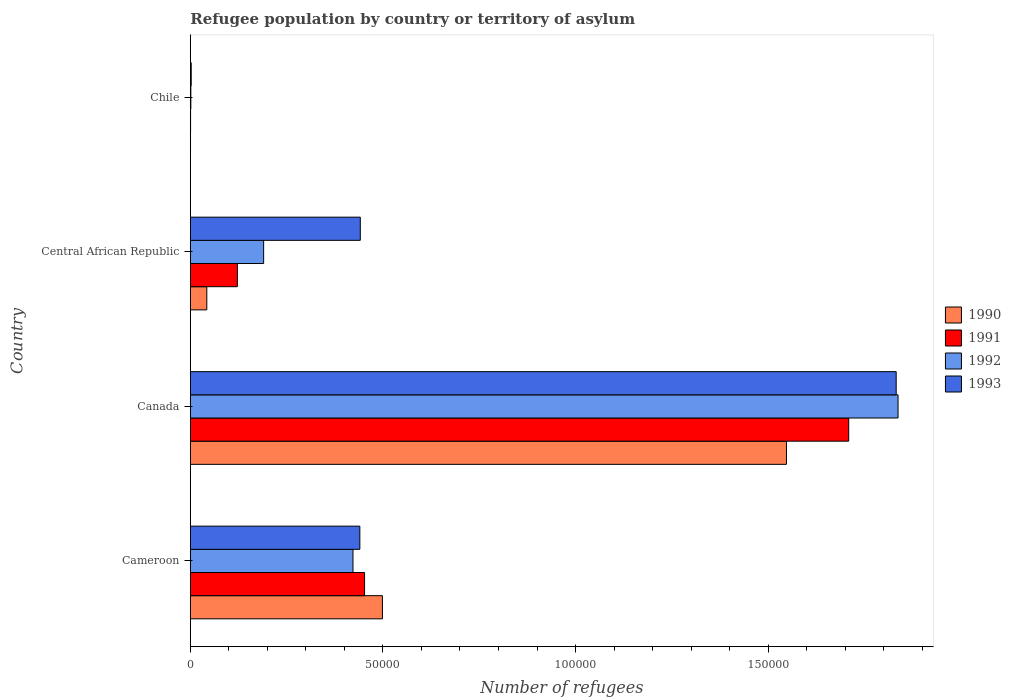How many different coloured bars are there?
Make the answer very short. 4. How many groups of bars are there?
Ensure brevity in your answer.  4. Are the number of bars on each tick of the Y-axis equal?
Your response must be concise. Yes. How many bars are there on the 2nd tick from the top?
Provide a short and direct response. 4. How many bars are there on the 1st tick from the bottom?
Your response must be concise. 4. What is the label of the 4th group of bars from the top?
Offer a terse response. Cameroon. In how many cases, is the number of bars for a given country not equal to the number of legend labels?
Keep it short and to the point. 0. What is the number of refugees in 1992 in Chile?
Ensure brevity in your answer.  142. Across all countries, what is the maximum number of refugees in 1993?
Offer a terse response. 1.83e+05. In which country was the number of refugees in 1991 maximum?
Ensure brevity in your answer.  Canada. What is the total number of refugees in 1990 in the graph?
Your response must be concise. 2.09e+05. What is the difference between the number of refugees in 1991 in Central African Republic and that in Chile?
Provide a succinct answer. 1.22e+04. What is the difference between the number of refugees in 1993 in Chile and the number of refugees in 1990 in Canada?
Make the answer very short. -1.55e+05. What is the average number of refugees in 1990 per country?
Make the answer very short. 5.22e+04. What is the difference between the number of refugees in 1990 and number of refugees in 1992 in Canada?
Make the answer very short. -2.90e+04. What is the ratio of the number of refugees in 1990 in Central African Republic to that in Chile?
Provide a short and direct response. 73.86. Is the number of refugees in 1993 in Cameroon less than that in Chile?
Keep it short and to the point. No. Is the difference between the number of refugees in 1990 in Cameroon and Chile greater than the difference between the number of refugees in 1992 in Cameroon and Chile?
Provide a short and direct response. Yes. What is the difference between the highest and the second highest number of refugees in 1992?
Make the answer very short. 1.41e+05. What is the difference between the highest and the lowest number of refugees in 1990?
Offer a terse response. 1.55e+05. In how many countries, is the number of refugees in 1991 greater than the average number of refugees in 1991 taken over all countries?
Keep it short and to the point. 1. Is the sum of the number of refugees in 1990 in Cameroon and Central African Republic greater than the maximum number of refugees in 1993 across all countries?
Offer a very short reply. No. Is it the case that in every country, the sum of the number of refugees in 1990 and number of refugees in 1993 is greater than the number of refugees in 1992?
Give a very brief answer. Yes. How many bars are there?
Give a very brief answer. 16. Are all the bars in the graph horizontal?
Keep it short and to the point. Yes. What is the difference between two consecutive major ticks on the X-axis?
Provide a short and direct response. 5.00e+04. Does the graph contain grids?
Offer a terse response. No. What is the title of the graph?
Ensure brevity in your answer.  Refugee population by country or territory of asylum. What is the label or title of the X-axis?
Provide a short and direct response. Number of refugees. What is the Number of refugees of 1990 in Cameroon?
Offer a very short reply. 4.99e+04. What is the Number of refugees in 1991 in Cameroon?
Your answer should be compact. 4.52e+04. What is the Number of refugees in 1992 in Cameroon?
Offer a terse response. 4.22e+04. What is the Number of refugees of 1993 in Cameroon?
Make the answer very short. 4.40e+04. What is the Number of refugees in 1990 in Canada?
Your answer should be very brief. 1.55e+05. What is the Number of refugees of 1991 in Canada?
Offer a terse response. 1.71e+05. What is the Number of refugees in 1992 in Canada?
Offer a very short reply. 1.84e+05. What is the Number of refugees in 1993 in Canada?
Ensure brevity in your answer.  1.83e+05. What is the Number of refugees in 1990 in Central African Republic?
Give a very brief answer. 4284. What is the Number of refugees in 1991 in Central African Republic?
Provide a succinct answer. 1.22e+04. What is the Number of refugees of 1992 in Central African Republic?
Ensure brevity in your answer.  1.90e+04. What is the Number of refugees of 1993 in Central African Republic?
Your answer should be compact. 4.41e+04. What is the Number of refugees of 1992 in Chile?
Offer a terse response. 142. What is the Number of refugees in 1993 in Chile?
Offer a terse response. 239. Across all countries, what is the maximum Number of refugees in 1990?
Offer a very short reply. 1.55e+05. Across all countries, what is the maximum Number of refugees in 1991?
Provide a short and direct response. 1.71e+05. Across all countries, what is the maximum Number of refugees of 1992?
Keep it short and to the point. 1.84e+05. Across all countries, what is the maximum Number of refugees in 1993?
Your response must be concise. 1.83e+05. Across all countries, what is the minimum Number of refugees in 1990?
Ensure brevity in your answer.  58. Across all countries, what is the minimum Number of refugees of 1991?
Your response must be concise. 72. Across all countries, what is the minimum Number of refugees in 1992?
Provide a short and direct response. 142. Across all countries, what is the minimum Number of refugees in 1993?
Give a very brief answer. 239. What is the total Number of refugees in 1990 in the graph?
Keep it short and to the point. 2.09e+05. What is the total Number of refugees of 1991 in the graph?
Give a very brief answer. 2.28e+05. What is the total Number of refugees in 1992 in the graph?
Ensure brevity in your answer.  2.45e+05. What is the total Number of refugees in 1993 in the graph?
Your response must be concise. 2.72e+05. What is the difference between the Number of refugees in 1990 in Cameroon and that in Canada?
Give a very brief answer. -1.05e+05. What is the difference between the Number of refugees in 1991 in Cameroon and that in Canada?
Keep it short and to the point. -1.26e+05. What is the difference between the Number of refugees in 1992 in Cameroon and that in Canada?
Your response must be concise. -1.41e+05. What is the difference between the Number of refugees in 1993 in Cameroon and that in Canada?
Provide a short and direct response. -1.39e+05. What is the difference between the Number of refugees of 1990 in Cameroon and that in Central African Republic?
Give a very brief answer. 4.56e+04. What is the difference between the Number of refugees of 1991 in Cameroon and that in Central African Republic?
Your answer should be very brief. 3.30e+04. What is the difference between the Number of refugees in 1992 in Cameroon and that in Central African Republic?
Offer a very short reply. 2.32e+04. What is the difference between the Number of refugees in 1993 in Cameroon and that in Central African Republic?
Your answer should be compact. -116. What is the difference between the Number of refugees of 1990 in Cameroon and that in Chile?
Your answer should be compact. 4.98e+04. What is the difference between the Number of refugees of 1991 in Cameroon and that in Chile?
Offer a very short reply. 4.52e+04. What is the difference between the Number of refugees in 1992 in Cameroon and that in Chile?
Ensure brevity in your answer.  4.21e+04. What is the difference between the Number of refugees of 1993 in Cameroon and that in Chile?
Offer a very short reply. 4.38e+04. What is the difference between the Number of refugees in 1990 in Canada and that in Central African Republic?
Give a very brief answer. 1.50e+05. What is the difference between the Number of refugees in 1991 in Canada and that in Central African Republic?
Your response must be concise. 1.59e+05. What is the difference between the Number of refugees in 1992 in Canada and that in Central African Republic?
Offer a terse response. 1.65e+05. What is the difference between the Number of refugees of 1993 in Canada and that in Central African Republic?
Provide a succinct answer. 1.39e+05. What is the difference between the Number of refugees in 1990 in Canada and that in Chile?
Offer a terse response. 1.55e+05. What is the difference between the Number of refugees in 1991 in Canada and that in Chile?
Make the answer very short. 1.71e+05. What is the difference between the Number of refugees of 1992 in Canada and that in Chile?
Your answer should be very brief. 1.84e+05. What is the difference between the Number of refugees of 1993 in Canada and that in Chile?
Make the answer very short. 1.83e+05. What is the difference between the Number of refugees in 1990 in Central African Republic and that in Chile?
Offer a terse response. 4226. What is the difference between the Number of refugees of 1991 in Central African Republic and that in Chile?
Provide a short and direct response. 1.22e+04. What is the difference between the Number of refugees of 1992 in Central African Republic and that in Chile?
Give a very brief answer. 1.89e+04. What is the difference between the Number of refugees in 1993 in Central African Republic and that in Chile?
Offer a terse response. 4.39e+04. What is the difference between the Number of refugees in 1990 in Cameroon and the Number of refugees in 1991 in Canada?
Your answer should be very brief. -1.21e+05. What is the difference between the Number of refugees in 1990 in Cameroon and the Number of refugees in 1992 in Canada?
Offer a terse response. -1.34e+05. What is the difference between the Number of refugees of 1990 in Cameroon and the Number of refugees of 1993 in Canada?
Give a very brief answer. -1.33e+05. What is the difference between the Number of refugees in 1991 in Cameroon and the Number of refugees in 1992 in Canada?
Offer a terse response. -1.38e+05. What is the difference between the Number of refugees of 1991 in Cameroon and the Number of refugees of 1993 in Canada?
Offer a terse response. -1.38e+05. What is the difference between the Number of refugees of 1992 in Cameroon and the Number of refugees of 1993 in Canada?
Your answer should be compact. -1.41e+05. What is the difference between the Number of refugees of 1990 in Cameroon and the Number of refugees of 1991 in Central African Republic?
Your response must be concise. 3.77e+04. What is the difference between the Number of refugees in 1990 in Cameroon and the Number of refugees in 1992 in Central African Republic?
Keep it short and to the point. 3.08e+04. What is the difference between the Number of refugees in 1990 in Cameroon and the Number of refugees in 1993 in Central African Republic?
Provide a short and direct response. 5747. What is the difference between the Number of refugees of 1991 in Cameroon and the Number of refugees of 1992 in Central African Republic?
Your answer should be compact. 2.62e+04. What is the difference between the Number of refugees of 1991 in Cameroon and the Number of refugees of 1993 in Central African Republic?
Ensure brevity in your answer.  1108. What is the difference between the Number of refugees of 1992 in Cameroon and the Number of refugees of 1993 in Central African Republic?
Make the answer very short. -1896. What is the difference between the Number of refugees of 1990 in Cameroon and the Number of refugees of 1991 in Chile?
Provide a short and direct response. 4.98e+04. What is the difference between the Number of refugees of 1990 in Cameroon and the Number of refugees of 1992 in Chile?
Provide a short and direct response. 4.97e+04. What is the difference between the Number of refugees in 1990 in Cameroon and the Number of refugees in 1993 in Chile?
Offer a very short reply. 4.96e+04. What is the difference between the Number of refugees in 1991 in Cameroon and the Number of refugees in 1992 in Chile?
Give a very brief answer. 4.51e+04. What is the difference between the Number of refugees in 1991 in Cameroon and the Number of refugees in 1993 in Chile?
Keep it short and to the point. 4.50e+04. What is the difference between the Number of refugees of 1992 in Cameroon and the Number of refugees of 1993 in Chile?
Make the answer very short. 4.20e+04. What is the difference between the Number of refugees in 1990 in Canada and the Number of refugees in 1991 in Central African Republic?
Ensure brevity in your answer.  1.43e+05. What is the difference between the Number of refugees of 1990 in Canada and the Number of refugees of 1992 in Central African Republic?
Offer a terse response. 1.36e+05. What is the difference between the Number of refugees in 1990 in Canada and the Number of refugees in 1993 in Central African Republic?
Your answer should be compact. 1.11e+05. What is the difference between the Number of refugees in 1991 in Canada and the Number of refugees in 1992 in Central African Republic?
Keep it short and to the point. 1.52e+05. What is the difference between the Number of refugees of 1991 in Canada and the Number of refugees of 1993 in Central African Republic?
Offer a terse response. 1.27e+05. What is the difference between the Number of refugees of 1992 in Canada and the Number of refugees of 1993 in Central African Republic?
Your answer should be compact. 1.40e+05. What is the difference between the Number of refugees of 1990 in Canada and the Number of refugees of 1991 in Chile?
Offer a very short reply. 1.55e+05. What is the difference between the Number of refugees of 1990 in Canada and the Number of refugees of 1992 in Chile?
Provide a succinct answer. 1.55e+05. What is the difference between the Number of refugees of 1990 in Canada and the Number of refugees of 1993 in Chile?
Ensure brevity in your answer.  1.55e+05. What is the difference between the Number of refugees of 1991 in Canada and the Number of refugees of 1992 in Chile?
Your answer should be very brief. 1.71e+05. What is the difference between the Number of refugees in 1991 in Canada and the Number of refugees in 1993 in Chile?
Keep it short and to the point. 1.71e+05. What is the difference between the Number of refugees in 1992 in Canada and the Number of refugees in 1993 in Chile?
Your answer should be compact. 1.83e+05. What is the difference between the Number of refugees in 1990 in Central African Republic and the Number of refugees in 1991 in Chile?
Provide a succinct answer. 4212. What is the difference between the Number of refugees of 1990 in Central African Republic and the Number of refugees of 1992 in Chile?
Provide a succinct answer. 4142. What is the difference between the Number of refugees of 1990 in Central African Republic and the Number of refugees of 1993 in Chile?
Keep it short and to the point. 4045. What is the difference between the Number of refugees of 1991 in Central African Republic and the Number of refugees of 1992 in Chile?
Keep it short and to the point. 1.21e+04. What is the difference between the Number of refugees of 1991 in Central African Republic and the Number of refugees of 1993 in Chile?
Your response must be concise. 1.20e+04. What is the difference between the Number of refugees of 1992 in Central African Republic and the Number of refugees of 1993 in Chile?
Your answer should be very brief. 1.88e+04. What is the average Number of refugees in 1990 per country?
Offer a very short reply. 5.22e+04. What is the average Number of refugees of 1991 per country?
Keep it short and to the point. 5.71e+04. What is the average Number of refugees of 1992 per country?
Your answer should be very brief. 6.13e+04. What is the average Number of refugees in 1993 per country?
Keep it short and to the point. 6.79e+04. What is the difference between the Number of refugees in 1990 and Number of refugees in 1991 in Cameroon?
Offer a terse response. 4639. What is the difference between the Number of refugees of 1990 and Number of refugees of 1992 in Cameroon?
Offer a terse response. 7643. What is the difference between the Number of refugees in 1990 and Number of refugees in 1993 in Cameroon?
Make the answer very short. 5863. What is the difference between the Number of refugees in 1991 and Number of refugees in 1992 in Cameroon?
Offer a terse response. 3004. What is the difference between the Number of refugees of 1991 and Number of refugees of 1993 in Cameroon?
Your response must be concise. 1224. What is the difference between the Number of refugees of 1992 and Number of refugees of 1993 in Cameroon?
Keep it short and to the point. -1780. What is the difference between the Number of refugees in 1990 and Number of refugees in 1991 in Canada?
Provide a succinct answer. -1.62e+04. What is the difference between the Number of refugees in 1990 and Number of refugees in 1992 in Canada?
Keep it short and to the point. -2.90e+04. What is the difference between the Number of refugees in 1990 and Number of refugees in 1993 in Canada?
Make the answer very short. -2.85e+04. What is the difference between the Number of refugees in 1991 and Number of refugees in 1992 in Canada?
Ensure brevity in your answer.  -1.28e+04. What is the difference between the Number of refugees in 1991 and Number of refugees in 1993 in Canada?
Offer a terse response. -1.23e+04. What is the difference between the Number of refugees in 1992 and Number of refugees in 1993 in Canada?
Your answer should be very brief. 482. What is the difference between the Number of refugees in 1990 and Number of refugees in 1991 in Central African Republic?
Offer a terse response. -7939. What is the difference between the Number of refugees in 1990 and Number of refugees in 1992 in Central African Republic?
Offer a very short reply. -1.48e+04. What is the difference between the Number of refugees of 1990 and Number of refugees of 1993 in Central African Republic?
Provide a short and direct response. -3.98e+04. What is the difference between the Number of refugees of 1991 and Number of refugees of 1992 in Central African Republic?
Give a very brief answer. -6817. What is the difference between the Number of refugees of 1991 and Number of refugees of 1993 in Central African Republic?
Provide a short and direct response. -3.19e+04. What is the difference between the Number of refugees of 1992 and Number of refugees of 1993 in Central African Republic?
Ensure brevity in your answer.  -2.51e+04. What is the difference between the Number of refugees of 1990 and Number of refugees of 1992 in Chile?
Your answer should be compact. -84. What is the difference between the Number of refugees in 1990 and Number of refugees in 1993 in Chile?
Provide a short and direct response. -181. What is the difference between the Number of refugees in 1991 and Number of refugees in 1992 in Chile?
Your response must be concise. -70. What is the difference between the Number of refugees of 1991 and Number of refugees of 1993 in Chile?
Make the answer very short. -167. What is the difference between the Number of refugees of 1992 and Number of refugees of 1993 in Chile?
Provide a short and direct response. -97. What is the ratio of the Number of refugees of 1990 in Cameroon to that in Canada?
Ensure brevity in your answer.  0.32. What is the ratio of the Number of refugees of 1991 in Cameroon to that in Canada?
Provide a succinct answer. 0.26. What is the ratio of the Number of refugees of 1992 in Cameroon to that in Canada?
Your answer should be compact. 0.23. What is the ratio of the Number of refugees of 1993 in Cameroon to that in Canada?
Provide a short and direct response. 0.24. What is the ratio of the Number of refugees of 1990 in Cameroon to that in Central African Republic?
Offer a terse response. 11.64. What is the ratio of the Number of refugees of 1991 in Cameroon to that in Central African Republic?
Your answer should be very brief. 3.7. What is the ratio of the Number of refugees of 1992 in Cameroon to that in Central African Republic?
Make the answer very short. 2.22. What is the ratio of the Number of refugees of 1990 in Cameroon to that in Chile?
Provide a succinct answer. 859.93. What is the ratio of the Number of refugees of 1991 in Cameroon to that in Chile?
Offer a very short reply. 628.29. What is the ratio of the Number of refugees of 1992 in Cameroon to that in Chile?
Your answer should be very brief. 297.42. What is the ratio of the Number of refugees of 1993 in Cameroon to that in Chile?
Your answer should be very brief. 184.15. What is the ratio of the Number of refugees of 1990 in Canada to that in Central African Republic?
Make the answer very short. 36.13. What is the ratio of the Number of refugees of 1991 in Canada to that in Central African Republic?
Provide a succinct answer. 13.98. What is the ratio of the Number of refugees of 1992 in Canada to that in Central African Republic?
Your answer should be very brief. 9.65. What is the ratio of the Number of refugees in 1993 in Canada to that in Central African Republic?
Your response must be concise. 4.15. What is the ratio of the Number of refugees of 1990 in Canada to that in Chile?
Your response must be concise. 2668.29. What is the ratio of the Number of refugees in 1991 in Canada to that in Chile?
Provide a succinct answer. 2373.83. What is the ratio of the Number of refugees in 1992 in Canada to that in Chile?
Give a very brief answer. 1293.82. What is the ratio of the Number of refugees of 1993 in Canada to that in Chile?
Ensure brevity in your answer.  766.7. What is the ratio of the Number of refugees of 1990 in Central African Republic to that in Chile?
Provide a succinct answer. 73.86. What is the ratio of the Number of refugees of 1991 in Central African Republic to that in Chile?
Provide a short and direct response. 169.76. What is the ratio of the Number of refugees of 1992 in Central African Republic to that in Chile?
Offer a very short reply. 134.08. What is the ratio of the Number of refugees in 1993 in Central African Republic to that in Chile?
Keep it short and to the point. 184.64. What is the difference between the highest and the second highest Number of refugees in 1990?
Make the answer very short. 1.05e+05. What is the difference between the highest and the second highest Number of refugees of 1991?
Offer a very short reply. 1.26e+05. What is the difference between the highest and the second highest Number of refugees of 1992?
Give a very brief answer. 1.41e+05. What is the difference between the highest and the second highest Number of refugees of 1993?
Provide a short and direct response. 1.39e+05. What is the difference between the highest and the lowest Number of refugees in 1990?
Offer a terse response. 1.55e+05. What is the difference between the highest and the lowest Number of refugees of 1991?
Give a very brief answer. 1.71e+05. What is the difference between the highest and the lowest Number of refugees in 1992?
Your answer should be compact. 1.84e+05. What is the difference between the highest and the lowest Number of refugees in 1993?
Your answer should be very brief. 1.83e+05. 